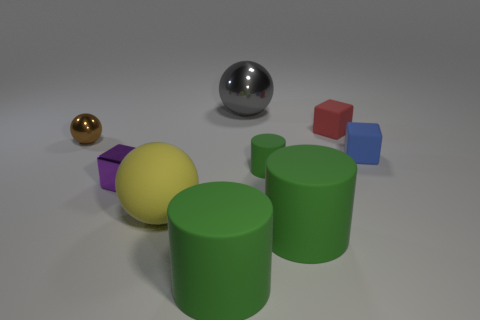Is the tiny red cube made of the same material as the tiny green cylinder?
Ensure brevity in your answer.  Yes. Are there any big gray metal balls in front of the large shiny ball?
Provide a short and direct response. No. What is the material of the tiny cube that is on the left side of the sphere behind the brown metallic sphere?
Ensure brevity in your answer.  Metal. There is a yellow object that is the same shape as the brown object; what size is it?
Make the answer very short. Large. What color is the small cube that is right of the large rubber ball and left of the small blue matte cube?
Your response must be concise. Red. Do the metallic thing that is in front of the blue matte cube and the small brown object have the same size?
Make the answer very short. Yes. Are the small blue object and the purple cube that is in front of the small green cylinder made of the same material?
Provide a succinct answer. No. How many cyan objects are small shiny cubes or small blocks?
Offer a very short reply. 0. Is there a cyan object?
Offer a very short reply. No. Is there a cylinder that is behind the big green rubber thing left of the object behind the red rubber thing?
Your answer should be very brief. Yes. 